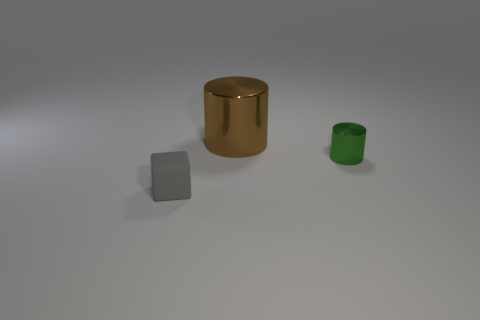How many things are small green metallic things or small objects that are right of the cube?
Keep it short and to the point. 1. Is the number of red rubber balls less than the number of large brown cylinders?
Your answer should be compact. Yes. Are there more big cylinders than tiny yellow metallic objects?
Provide a short and direct response. Yes. What number of other objects are the same material as the tiny gray block?
Offer a very short reply. 0. How many blocks are on the right side of the small thing left of the metallic cylinder that is behind the small green metallic object?
Keep it short and to the point. 0. What number of metallic things are either small objects or tiny gray objects?
Your answer should be very brief. 1. What size is the object left of the metallic object that is left of the tiny shiny object?
Your answer should be very brief. Small. Do the metallic cylinder that is to the right of the large brown thing and the object to the left of the brown metal thing have the same color?
Give a very brief answer. No. What color is the object that is both behind the tiny gray matte block and in front of the large cylinder?
Keep it short and to the point. Green. Are the gray thing and the large cylinder made of the same material?
Ensure brevity in your answer.  No. 